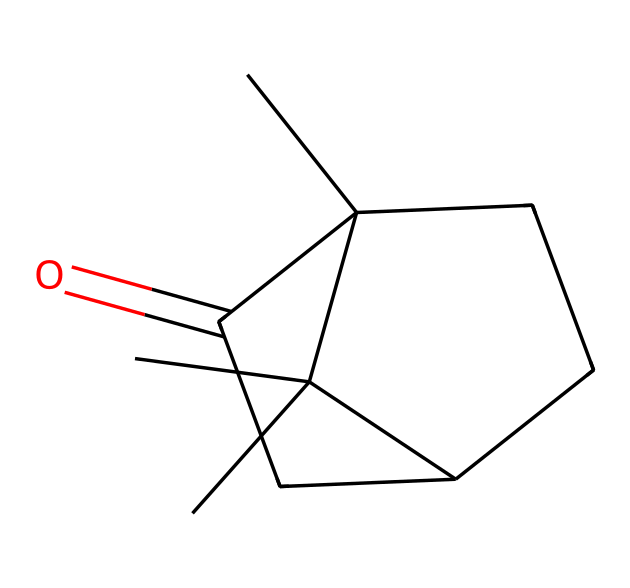What is the molecular formula of camphor? To determine the molecular formula, we analyze the SMILES representation and count each type of atom present in the structure. From the SMILES, we can identify 10 carbon (C) atoms, 16 hydrogen (H) atoms, and 1 oxygen (O) atom. Therefore, the molecular formula is C10H16O.
Answer: C10H16O How many rings are present in the structure of camphor? By examining the structure represented in the SMILES, we can identify that there are two rings present. The code "C2CCC1" suggests the existence of two interconnected cyclic hydrocarbon structures.
Answer: 2 What functional group is present in camphor? Analyzing the SMILES reveals the presence of a carbonyl group (C=O), which is characteristic of ketones. This specific functional group is important for the classification of camphor as a ketone.
Answer: carbonyl group Does camphor contain a double bond? In the SMILES notation, there is a representation of a carbonyl (=O) indicating that there is a double bond between carbon and oxygen. Hence, camphor contains a double bond.
Answer: yes What is the significance of the carbonyl location in camphor? The position of the carbonyl group (C=O) is critical as it defines camphor's classification as a ketone. Specifically, the carbonyl is located within the structure, indicating its position affects the chemical properties and reactivity of the compound.
Answer: ketone classification What is the total number of hydrogen atoms attached to the carbon skeleton in camphor? The analysis of the SMILES shows that all carbon atoms are connected to enough hydrogen atoms to satisfy the tetravalency of carbon. Counting these directly from the structure gives a total of 16 hydrogen atoms.
Answer: 16 